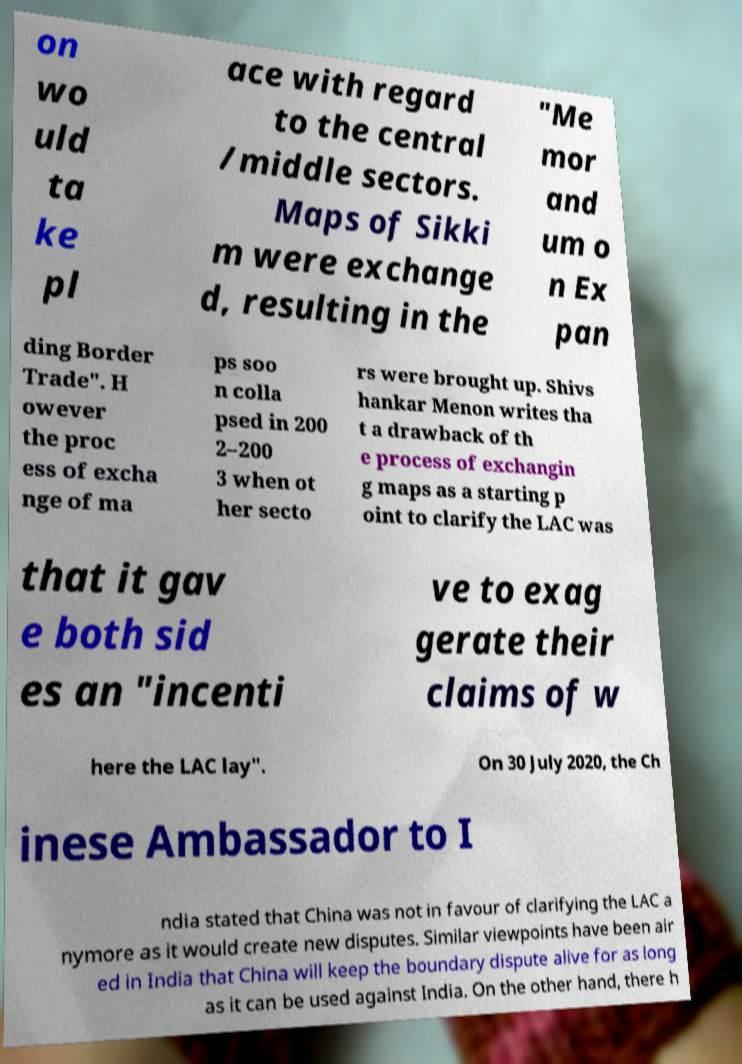I need the written content from this picture converted into text. Can you do that? on wo uld ta ke pl ace with regard to the central /middle sectors. Maps of Sikki m were exchange d, resulting in the "Me mor and um o n Ex pan ding Border Trade". H owever the proc ess of excha nge of ma ps soo n colla psed in 200 2–200 3 when ot her secto rs were brought up. Shivs hankar Menon writes tha t a drawback of th e process of exchangin g maps as a starting p oint to clarify the LAC was that it gav e both sid es an "incenti ve to exag gerate their claims of w here the LAC lay". On 30 July 2020, the Ch inese Ambassador to I ndia stated that China was not in favour of clarifying the LAC a nymore as it would create new disputes. Similar viewpoints have been air ed in India that China will keep the boundary dispute alive for as long as it can be used against India. On the other hand, there h 